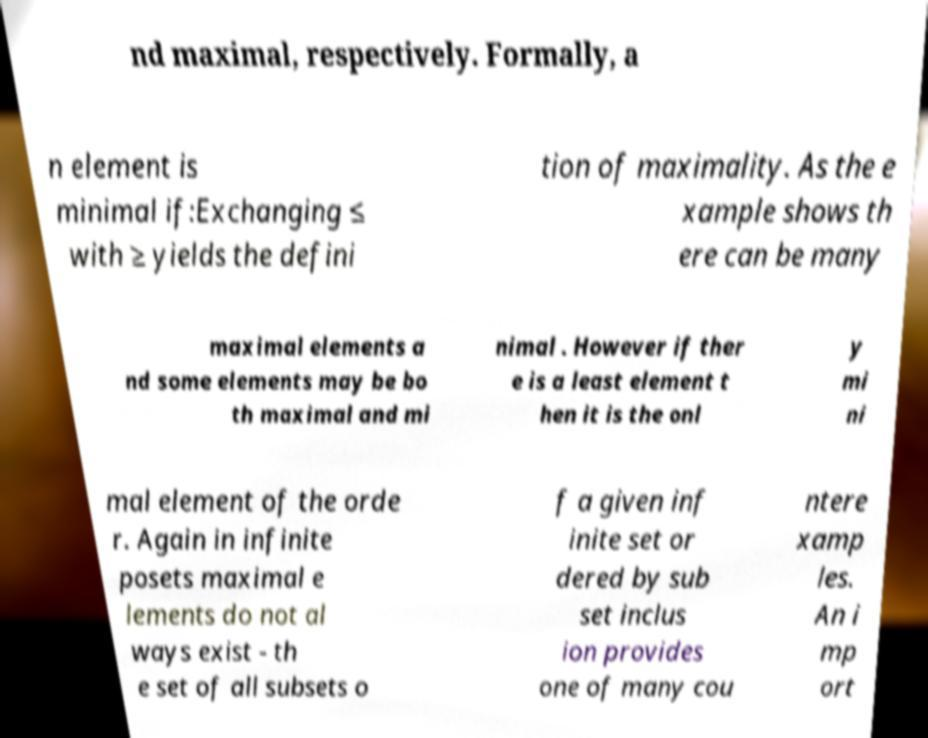What messages or text are displayed in this image? I need them in a readable, typed format. nd maximal, respectively. Formally, a n element is minimal if:Exchanging ≤ with ≥ yields the defini tion of maximality. As the e xample shows th ere can be many maximal elements a nd some elements may be bo th maximal and mi nimal . However if ther e is a least element t hen it is the onl y mi ni mal element of the orde r. Again in infinite posets maximal e lements do not al ways exist - th e set of all subsets o f a given inf inite set or dered by sub set inclus ion provides one of many cou ntere xamp les. An i mp ort 